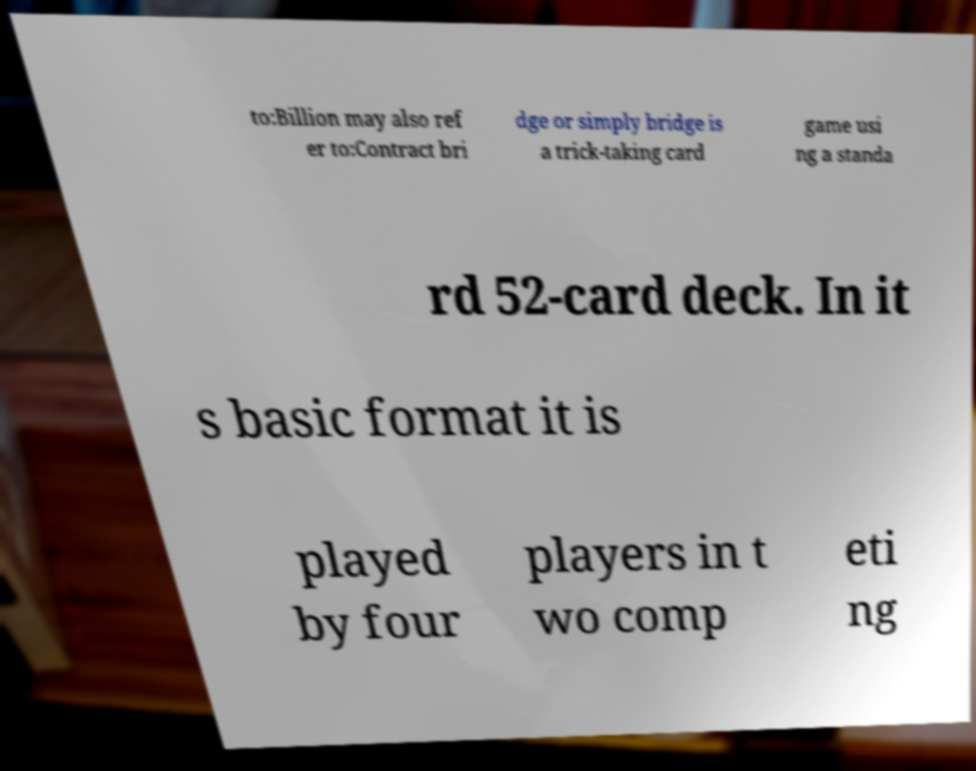Could you extract and type out the text from this image? to:Billion may also ref er to:Contract bri dge or simply bridge is a trick-taking card game usi ng a standa rd 52-card deck. In it s basic format it is played by four players in t wo comp eti ng 